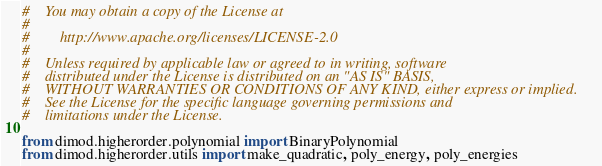Convert code to text. <code><loc_0><loc_0><loc_500><loc_500><_Python_>#    You may obtain a copy of the License at
#
#        http://www.apache.org/licenses/LICENSE-2.0
#
#    Unless required by applicable law or agreed to in writing, software
#    distributed under the License is distributed on an "AS IS" BASIS,
#    WITHOUT WARRANTIES OR CONDITIONS OF ANY KIND, either express or implied.
#    See the License for the specific language governing permissions and
#    limitations under the License.

from dimod.higherorder.polynomial import BinaryPolynomial
from dimod.higherorder.utils import make_quadratic, poly_energy, poly_energies
</code> 